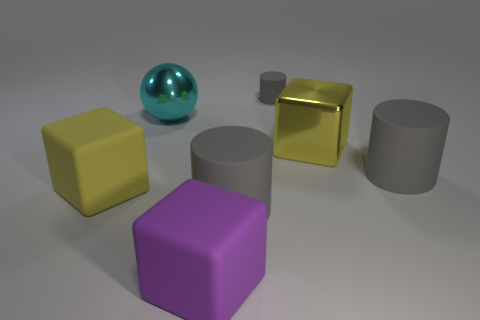Subtract all big rubber blocks. How many blocks are left? 1 Subtract all purple blocks. How many blocks are left? 2 Add 1 spheres. How many objects exist? 8 Subtract all cylinders. How many objects are left? 4 Subtract 1 balls. How many balls are left? 0 Subtract all red spheres. How many yellow cubes are left? 2 Subtract all tiny purple rubber things. Subtract all yellow matte things. How many objects are left? 6 Add 7 cyan balls. How many cyan balls are left? 8 Add 4 large metal things. How many large metal things exist? 6 Subtract 0 brown balls. How many objects are left? 7 